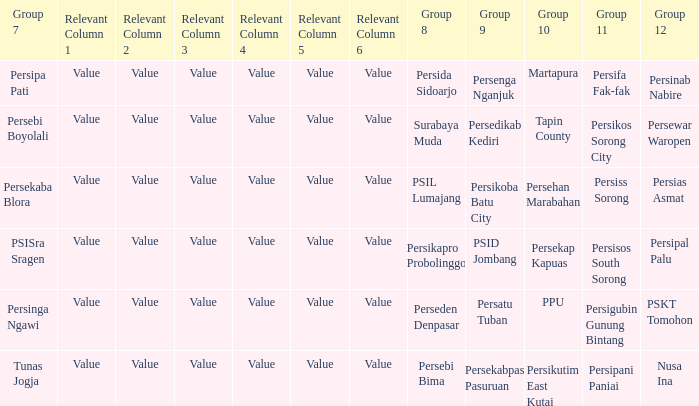Who played in group 8 when Persinab Nabire played in Group 12? Persida Sidoarjo. 